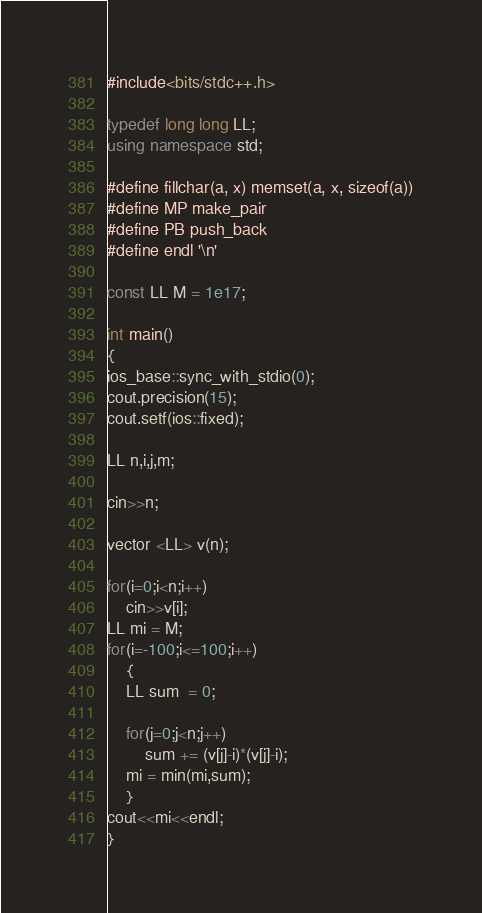<code> <loc_0><loc_0><loc_500><loc_500><_C++_>
#include<bits/stdc++.h>

typedef long long LL;  
using namespace std;

#define fillchar(a, x) memset(a, x, sizeof(a))
#define MP make_pair
#define PB push_back
#define endl '\n'

const LL M = 1e17;

int main()
{
ios_base::sync_with_stdio(0); 
cout.precision(15);
cout.setf(ios::fixed);

LL n,i,j,m;

cin>>n;

vector <LL> v(n);

for(i=0;i<n;i++)
	cin>>v[i];
LL mi = M;
for(i=-100;i<=100;i++)
	{
	LL sum  = 0;
	
	for(j=0;j<n;j++)
		sum += (v[j]-i)*(v[j]-i);
	mi = min(mi,sum);
	}
cout<<mi<<endl;
}
</code> 